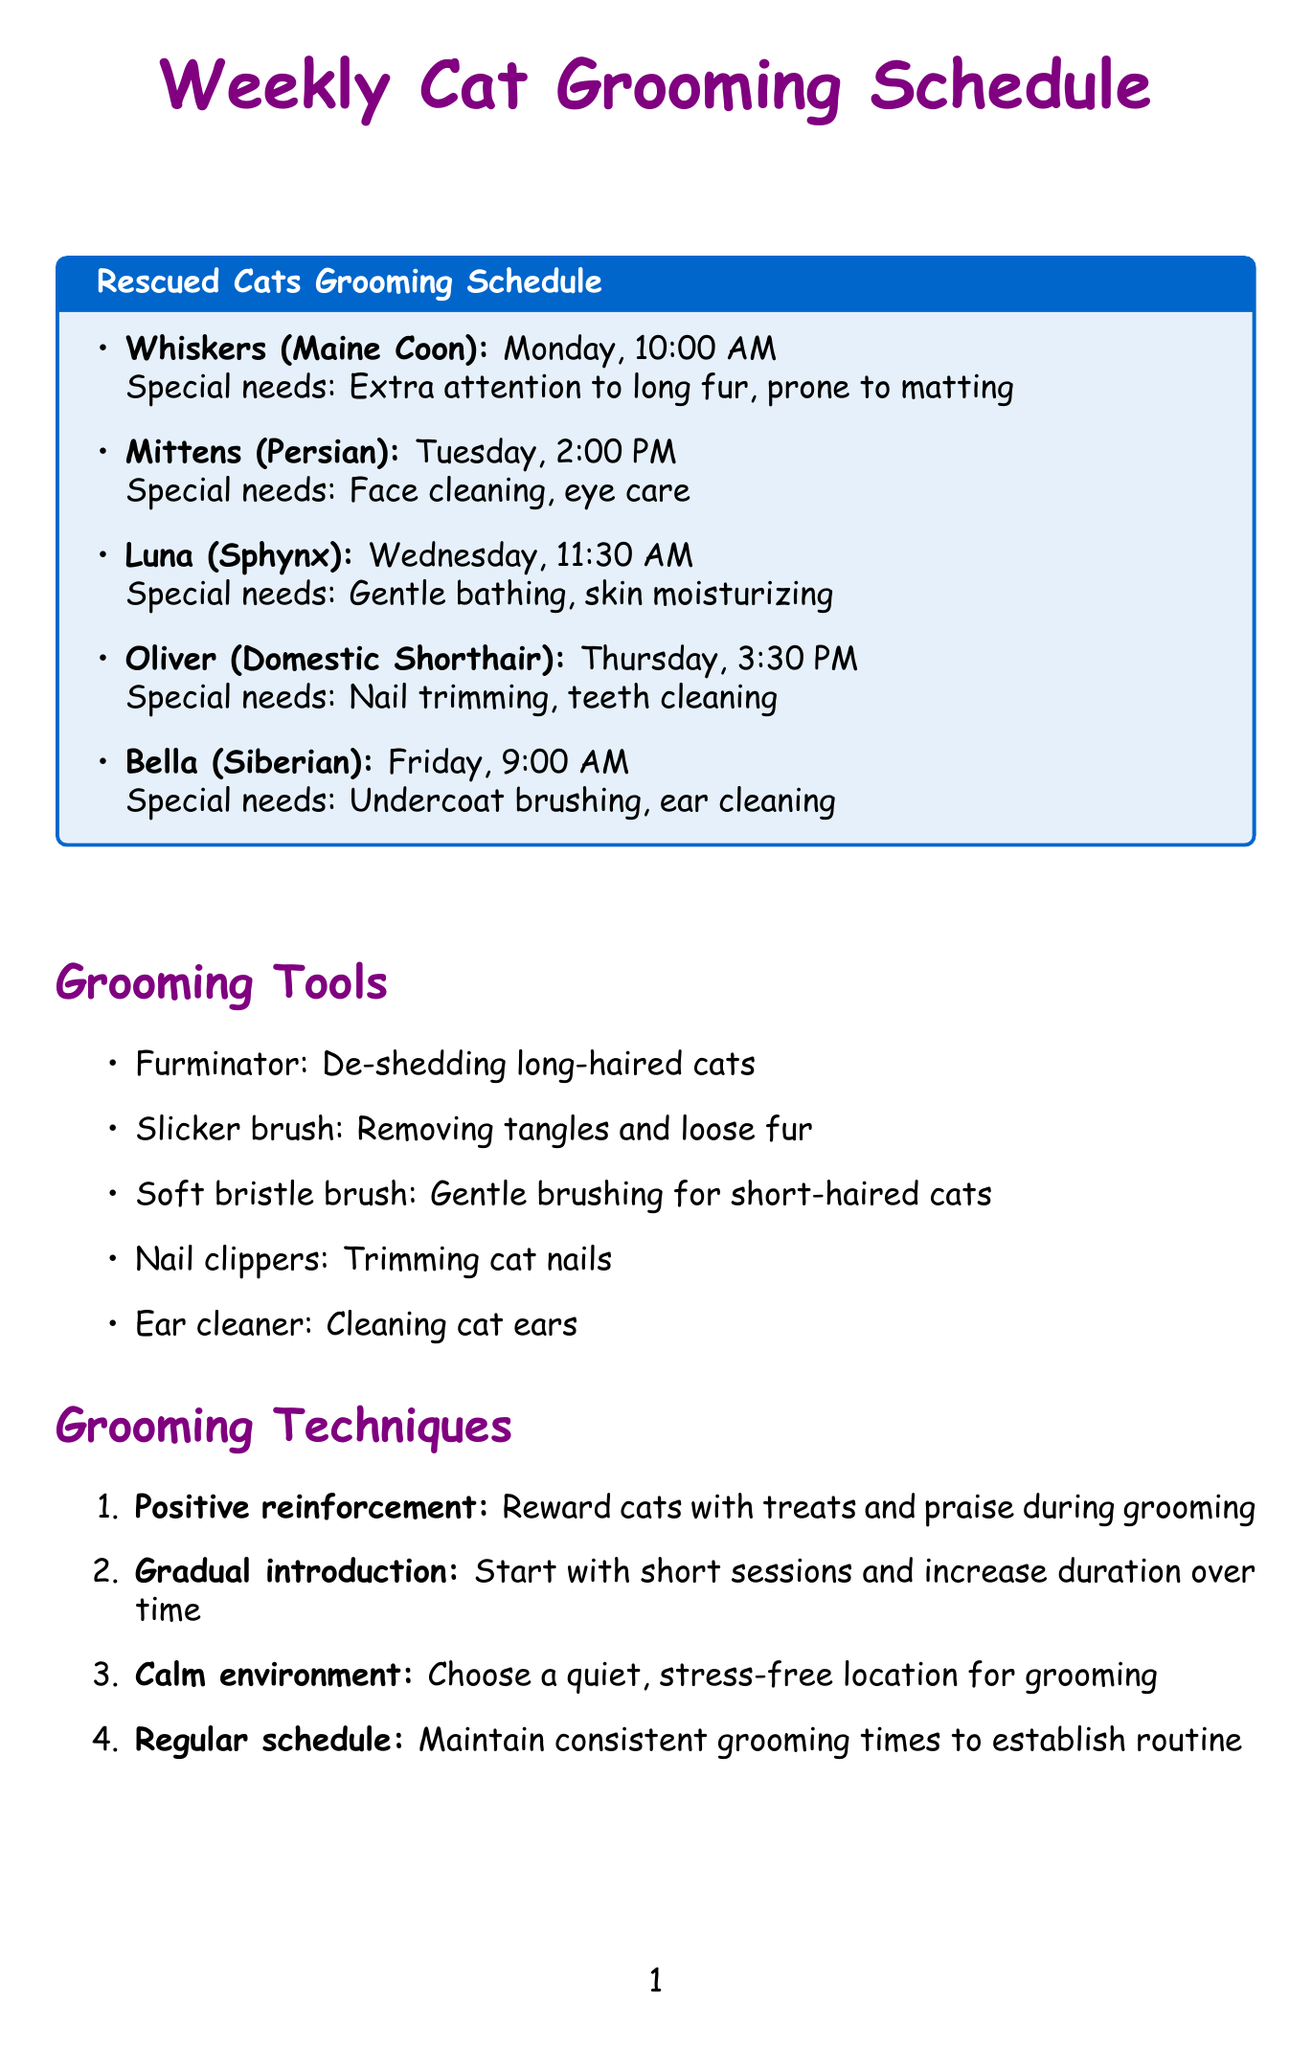What day is Whiskers scheduled for grooming? Whiskers is scheduled for grooming on Monday, as listed in the grooming schedule.
Answer: Monday What special needs does Mittens have? Mittens requires face cleaning and eye care during grooming, which is noted in the document.
Answer: Face cleaning, eye care What time is Luna's grooming session? Luna's grooming session is scheduled for 11:30 AM on Wednesday, as specified in the schedule.
Answer: 11:30 AM Which grooming tool is used for trimming cat nails? The document specifically mentions nail clippers as the grooming tool for trimming cat nails.
Answer: Nail clippers Which cat has the special need for nail trimming? Oliver has a special need for nail trimming, which is included in his grooming details.
Answer: Oliver How many minutes is playtime scheduled after grooming? The playtime scheduled after grooming is noted as 15 minutes in the post-grooming activities section.
Answer: 15 minutes On which day is Bella scheduled for grooming? Bella is scheduled for grooming on Friday, as indicated in the schedule.
Answer: Friday What is the primary technique used for introducing cats to grooming? The document suggests using gradual introduction as the primary technique for grooming sessions.
Answer: Gradual introduction What is the benefit of grooming mentioned in the document? One of the benefits of grooming noted is early detection of skin issues.
Answer: Early detection of skin issues 